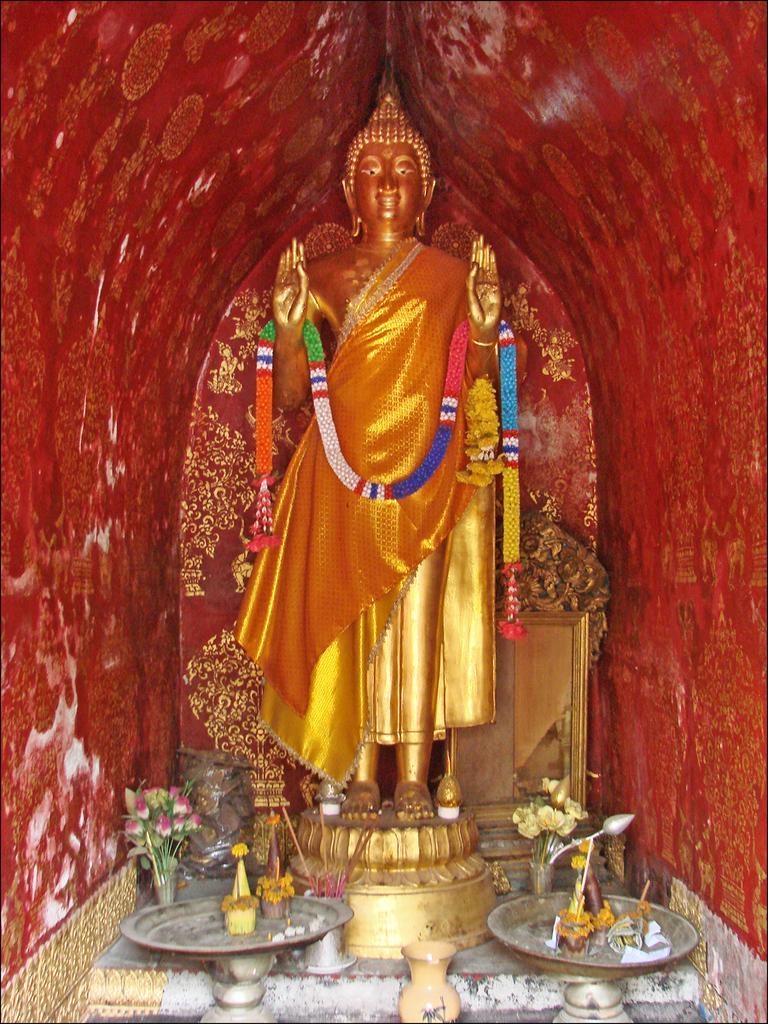Please provide a concise description of this image. In this image in the center there is a statue and there are garlands, flowers and some vessels mirror. And in the background there is wall, on the wall there is some art. 